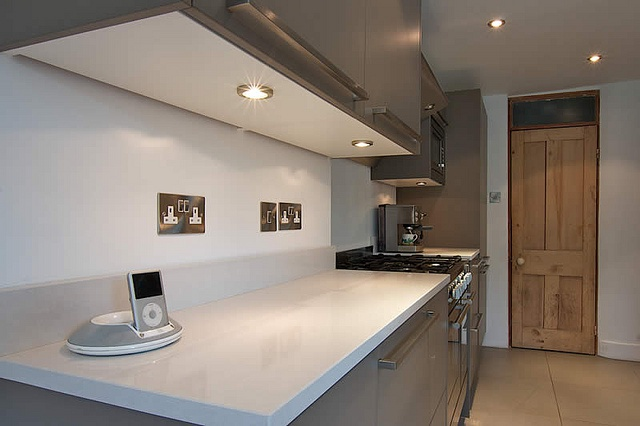Describe the objects in this image and their specific colors. I can see oven in black and gray tones and microwave in black and gray tones in this image. 